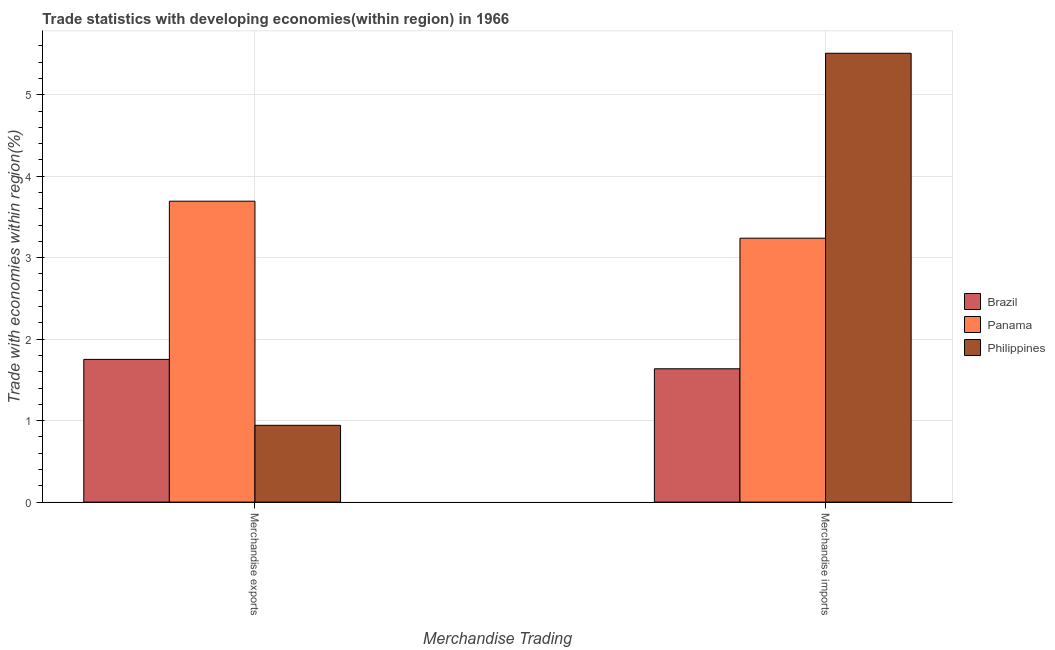What is the merchandise exports in Philippines?
Your response must be concise. 0.94. Across all countries, what is the maximum merchandise exports?
Ensure brevity in your answer.  3.69. Across all countries, what is the minimum merchandise exports?
Offer a very short reply. 0.94. In which country was the merchandise exports maximum?
Keep it short and to the point. Panama. In which country was the merchandise exports minimum?
Offer a very short reply. Philippines. What is the total merchandise exports in the graph?
Ensure brevity in your answer.  6.39. What is the difference between the merchandise imports in Panama and that in Philippines?
Offer a very short reply. -2.27. What is the difference between the merchandise imports in Panama and the merchandise exports in Brazil?
Your response must be concise. 1.49. What is the average merchandise exports per country?
Provide a succinct answer. 2.13. What is the difference between the merchandise imports and merchandise exports in Brazil?
Your answer should be compact. -0.12. In how many countries, is the merchandise imports greater than 3.2 %?
Make the answer very short. 2. What is the ratio of the merchandise imports in Panama to that in Brazil?
Your response must be concise. 1.98. Is the merchandise exports in Panama less than that in Philippines?
Offer a terse response. No. What does the 2nd bar from the left in Merchandise exports represents?
Offer a terse response. Panama. What does the 2nd bar from the right in Merchandise imports represents?
Offer a terse response. Panama. How many countries are there in the graph?
Offer a very short reply. 3. Are the values on the major ticks of Y-axis written in scientific E-notation?
Ensure brevity in your answer.  No. Does the graph contain grids?
Your answer should be compact. Yes. Where does the legend appear in the graph?
Make the answer very short. Center right. How many legend labels are there?
Ensure brevity in your answer.  3. What is the title of the graph?
Your answer should be compact. Trade statistics with developing economies(within region) in 1966. What is the label or title of the X-axis?
Offer a very short reply. Merchandise Trading. What is the label or title of the Y-axis?
Provide a short and direct response. Trade with economies within region(%). What is the Trade with economies within region(%) in Brazil in Merchandise exports?
Your answer should be compact. 1.75. What is the Trade with economies within region(%) in Panama in Merchandise exports?
Provide a succinct answer. 3.69. What is the Trade with economies within region(%) of Philippines in Merchandise exports?
Make the answer very short. 0.94. What is the Trade with economies within region(%) in Brazil in Merchandise imports?
Your answer should be compact. 1.64. What is the Trade with economies within region(%) in Panama in Merchandise imports?
Provide a succinct answer. 3.24. What is the Trade with economies within region(%) of Philippines in Merchandise imports?
Keep it short and to the point. 5.51. Across all Merchandise Trading, what is the maximum Trade with economies within region(%) in Brazil?
Ensure brevity in your answer.  1.75. Across all Merchandise Trading, what is the maximum Trade with economies within region(%) of Panama?
Your answer should be compact. 3.69. Across all Merchandise Trading, what is the maximum Trade with economies within region(%) of Philippines?
Your response must be concise. 5.51. Across all Merchandise Trading, what is the minimum Trade with economies within region(%) in Brazil?
Make the answer very short. 1.64. Across all Merchandise Trading, what is the minimum Trade with economies within region(%) of Panama?
Your response must be concise. 3.24. Across all Merchandise Trading, what is the minimum Trade with economies within region(%) in Philippines?
Your answer should be very brief. 0.94. What is the total Trade with economies within region(%) of Brazil in the graph?
Your response must be concise. 3.39. What is the total Trade with economies within region(%) in Panama in the graph?
Make the answer very short. 6.93. What is the total Trade with economies within region(%) of Philippines in the graph?
Your response must be concise. 6.45. What is the difference between the Trade with economies within region(%) of Brazil in Merchandise exports and that in Merchandise imports?
Provide a short and direct response. 0.12. What is the difference between the Trade with economies within region(%) in Panama in Merchandise exports and that in Merchandise imports?
Provide a succinct answer. 0.45. What is the difference between the Trade with economies within region(%) in Philippines in Merchandise exports and that in Merchandise imports?
Your answer should be very brief. -4.57. What is the difference between the Trade with economies within region(%) of Brazil in Merchandise exports and the Trade with economies within region(%) of Panama in Merchandise imports?
Offer a terse response. -1.49. What is the difference between the Trade with economies within region(%) of Brazil in Merchandise exports and the Trade with economies within region(%) of Philippines in Merchandise imports?
Your response must be concise. -3.76. What is the difference between the Trade with economies within region(%) of Panama in Merchandise exports and the Trade with economies within region(%) of Philippines in Merchandise imports?
Provide a succinct answer. -1.82. What is the average Trade with economies within region(%) of Brazil per Merchandise Trading?
Make the answer very short. 1.69. What is the average Trade with economies within region(%) in Panama per Merchandise Trading?
Provide a succinct answer. 3.47. What is the average Trade with economies within region(%) in Philippines per Merchandise Trading?
Your answer should be very brief. 3.23. What is the difference between the Trade with economies within region(%) of Brazil and Trade with economies within region(%) of Panama in Merchandise exports?
Your response must be concise. -1.94. What is the difference between the Trade with economies within region(%) of Brazil and Trade with economies within region(%) of Philippines in Merchandise exports?
Keep it short and to the point. 0.81. What is the difference between the Trade with economies within region(%) of Panama and Trade with economies within region(%) of Philippines in Merchandise exports?
Keep it short and to the point. 2.75. What is the difference between the Trade with economies within region(%) in Brazil and Trade with economies within region(%) in Panama in Merchandise imports?
Offer a very short reply. -1.6. What is the difference between the Trade with economies within region(%) of Brazil and Trade with economies within region(%) of Philippines in Merchandise imports?
Offer a terse response. -3.87. What is the difference between the Trade with economies within region(%) in Panama and Trade with economies within region(%) in Philippines in Merchandise imports?
Give a very brief answer. -2.27. What is the ratio of the Trade with economies within region(%) of Brazil in Merchandise exports to that in Merchandise imports?
Give a very brief answer. 1.07. What is the ratio of the Trade with economies within region(%) in Panama in Merchandise exports to that in Merchandise imports?
Make the answer very short. 1.14. What is the ratio of the Trade with economies within region(%) of Philippines in Merchandise exports to that in Merchandise imports?
Your response must be concise. 0.17. What is the difference between the highest and the second highest Trade with economies within region(%) of Brazil?
Provide a short and direct response. 0.12. What is the difference between the highest and the second highest Trade with economies within region(%) in Panama?
Offer a terse response. 0.45. What is the difference between the highest and the second highest Trade with economies within region(%) in Philippines?
Keep it short and to the point. 4.57. What is the difference between the highest and the lowest Trade with economies within region(%) of Brazil?
Your response must be concise. 0.12. What is the difference between the highest and the lowest Trade with economies within region(%) in Panama?
Your answer should be very brief. 0.45. What is the difference between the highest and the lowest Trade with economies within region(%) of Philippines?
Ensure brevity in your answer.  4.57. 